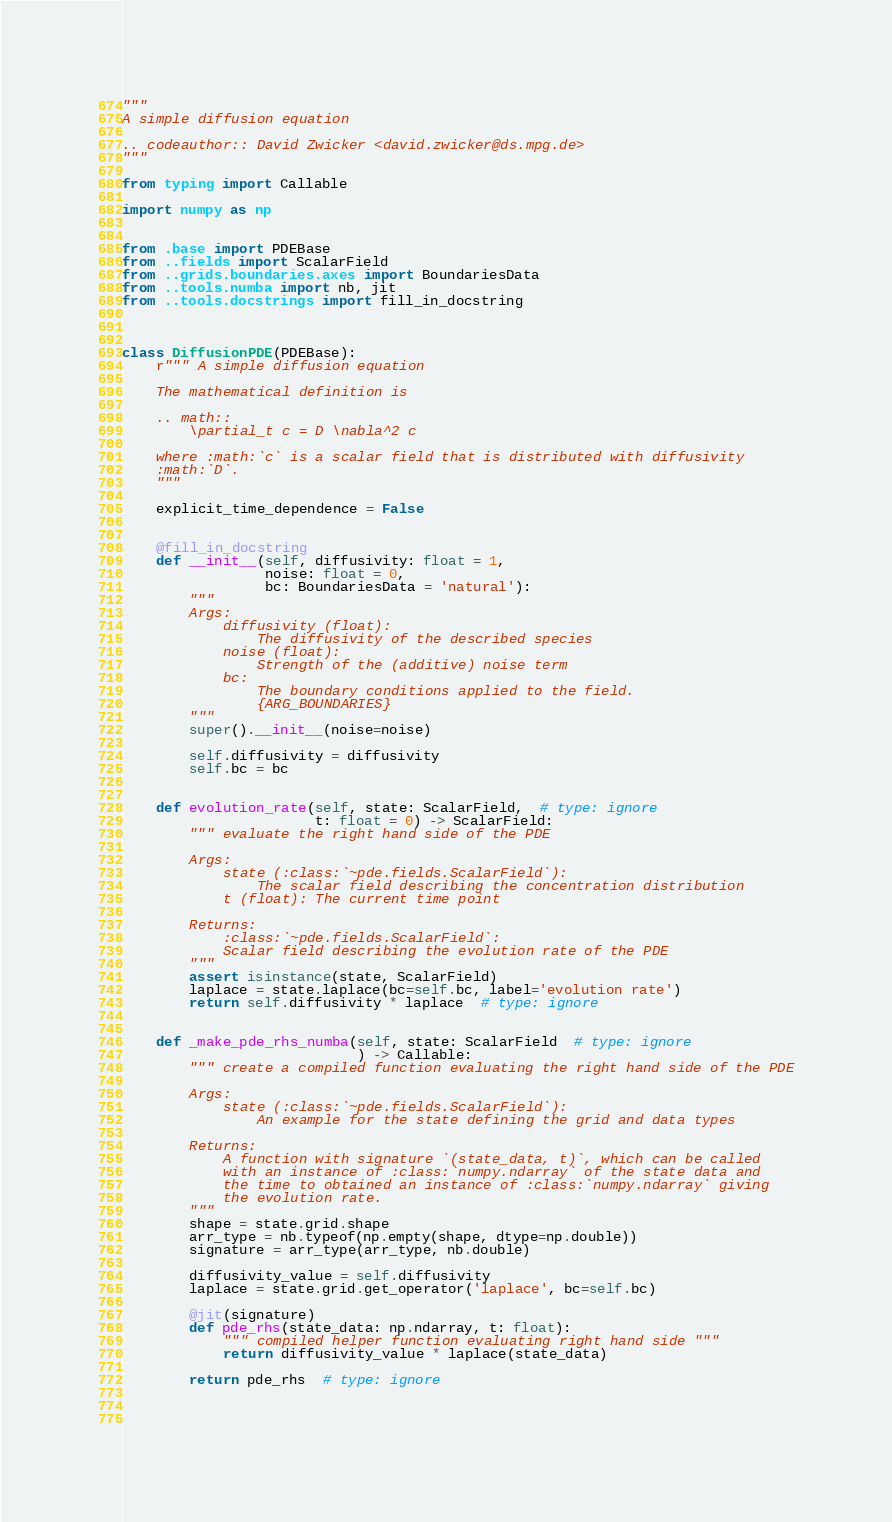<code> <loc_0><loc_0><loc_500><loc_500><_Python_>"""
A simple diffusion equation

.. codeauthor:: David Zwicker <david.zwicker@ds.mpg.de> 
"""

from typing import Callable

import numpy as np


from .base import PDEBase
from ..fields import ScalarField
from ..grids.boundaries.axes import BoundariesData
from ..tools.numba import nb, jit
from ..tools.docstrings import fill_in_docstring


        
class DiffusionPDE(PDEBase):
    r""" A simple diffusion equation
    
    The mathematical definition is

    .. math::
        \partial_t c = D \nabla^2 c
        
    where :math:`c` is a scalar field that is distributed with diffusivity
    :math:`D`.
    """

    explicit_time_dependence = False
    
    
    @fill_in_docstring
    def __init__(self, diffusivity: float = 1,
                 noise: float = 0,
                 bc: BoundariesData = 'natural'):
        """ 
        Args:
            diffusivity (float):
                The diffusivity of the described species
            noise (float):
                Strength of the (additive) noise term
            bc:
                The boundary conditions applied to the field.
                {ARG_BOUNDARIES} 
        """
        super().__init__(noise=noise)
        
        self.diffusivity = diffusivity
        self.bc = bc
            
            
    def evolution_rate(self, state: ScalarField,  # type: ignore
                       t: float = 0) -> ScalarField:
        """ evaluate the right hand side of the PDE
        
        Args:
            state (:class:`~pde.fields.ScalarField`):
                The scalar field describing the concentration distribution
            t (float): The current time point
            
        Returns:
            :class:`~pde.fields.ScalarField`:
            Scalar field describing the evolution rate of the PDE 
        """
        assert isinstance(state, ScalarField)
        laplace = state.laplace(bc=self.bc, label='evolution rate')
        return self.diffusivity * laplace  # type: ignore
    
    
    def _make_pde_rhs_numba(self, state: ScalarField  # type: ignore
                            ) -> Callable:
        """ create a compiled function evaluating the right hand side of the PDE
        
        Args:
            state (:class:`~pde.fields.ScalarField`):
                An example for the state defining the grid and data types
                
        Returns:
            A function with signature `(state_data, t)`, which can be called
            with an instance of :class:`numpy.ndarray` of the state data and
            the time to obtained an instance of :class:`numpy.ndarray` giving
            the evolution rate.  
        """
        shape = state.grid.shape
        arr_type = nb.typeof(np.empty(shape, dtype=np.double))
        signature = arr_type(arr_type, nb.double)
        
        diffusivity_value = self.diffusivity
        laplace = state.grid.get_operator('laplace', bc=self.bc)

        @jit(signature)
        def pde_rhs(state_data: np.ndarray, t: float):
            """ compiled helper function evaluating right hand side """ 
            return diffusivity_value * laplace(state_data) 
            
        return pde_rhs  # type: ignore
    
    
    
</code> 